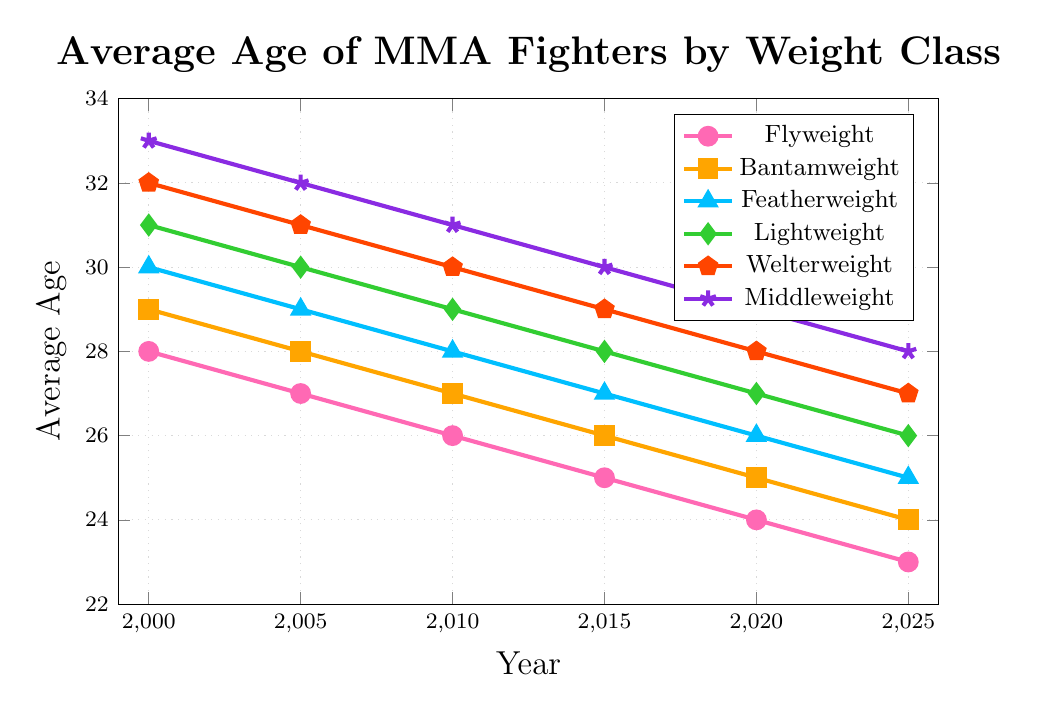Which weight class had the highest average age in 2000? Look at the 2000 data for each weight class. The Middleweight class has the highest value at 33.
Answer: Middleweight Which weight class had the fastest decrease in average age from 2000 to 2025? Calculate the differences from 2000 to 2025 for each weight class. Flyweight decreases by 5 (28 to 23), Bantamweight by 5 (29 to 24), Featherweight by 5 (30 to 25), Lightweight by 5 (31 to 26), Welterweight by 5 (32 to 27), Middleweight by 5 (33 to 28). They all have the same rate of decrease.
Answer: All classes What is the average age of Bantamweight fighters in 2010? Find the data point for Bantamweight in 2010. It is 27.
Answer: 27 How does the average age of Featherweight fighters in 2010 compare to that in 2025? Look at the Featherweight information in 2010 (28) and 2025 (25). 28 is greater than 25.
Answer: 28 is greater What is the total decrease in average age for Welterweight fighters from 2000 to 2025? Subtract the 2025 value from the 2000 value for Welterweight. 32 - 27 = 5.
Answer: 5 Which weight class had the lowest average age in 2025? Look at the data points for 2025. Flyweight has the lowest value at 23.
Answer: Flyweight Between which years did Middleweight fighters see the largest decrease in their average age? Compare the yearly changes in values for Middleweight: 
  2000 to 2005: 33 - 32 = 1 
  2005 to 2010: 32 - 31 = 1 
  2010 to 2015: 31 - 30 = 1 
  2015 to 2020: 30 - 29 = 1 
  2020 to 2025: 29 - 28 = 1 
All years had an equal decrease of 1.
Answer: All equal By how many years did the average age of Flyweight fighters drop from 2000 to 2020? Subtract the 2020 value from the 2000 value for Flyweight. 28 - 24 = 4.
Answer: 4 Which weight class in 2010 had an average age that was exactly 29? Look at the 2010 data points. Lightweight has an average age of 29.
Answer: Lightweight 